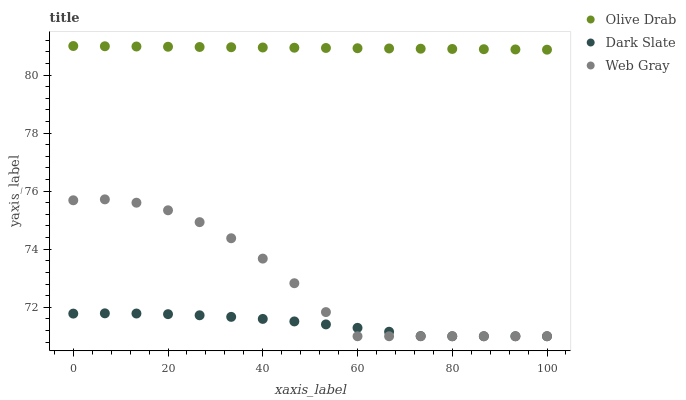Does Dark Slate have the minimum area under the curve?
Answer yes or no. Yes. Does Olive Drab have the maximum area under the curve?
Answer yes or no. Yes. Does Web Gray have the minimum area under the curve?
Answer yes or no. No. Does Web Gray have the maximum area under the curve?
Answer yes or no. No. Is Olive Drab the smoothest?
Answer yes or no. Yes. Is Web Gray the roughest?
Answer yes or no. Yes. Is Web Gray the smoothest?
Answer yes or no. No. Is Olive Drab the roughest?
Answer yes or no. No. Does Dark Slate have the lowest value?
Answer yes or no. Yes. Does Olive Drab have the lowest value?
Answer yes or no. No. Does Olive Drab have the highest value?
Answer yes or no. Yes. Does Web Gray have the highest value?
Answer yes or no. No. Is Web Gray less than Olive Drab?
Answer yes or no. Yes. Is Olive Drab greater than Web Gray?
Answer yes or no. Yes. Does Dark Slate intersect Web Gray?
Answer yes or no. Yes. Is Dark Slate less than Web Gray?
Answer yes or no. No. Is Dark Slate greater than Web Gray?
Answer yes or no. No. Does Web Gray intersect Olive Drab?
Answer yes or no. No. 